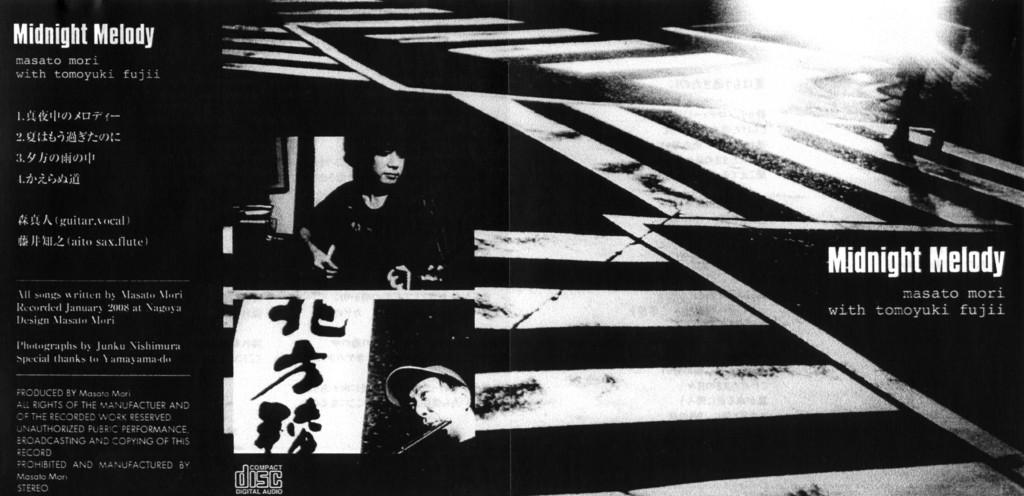<image>
Write a terse but informative summary of the picture. a cover for some CD that says midnight melody on it 